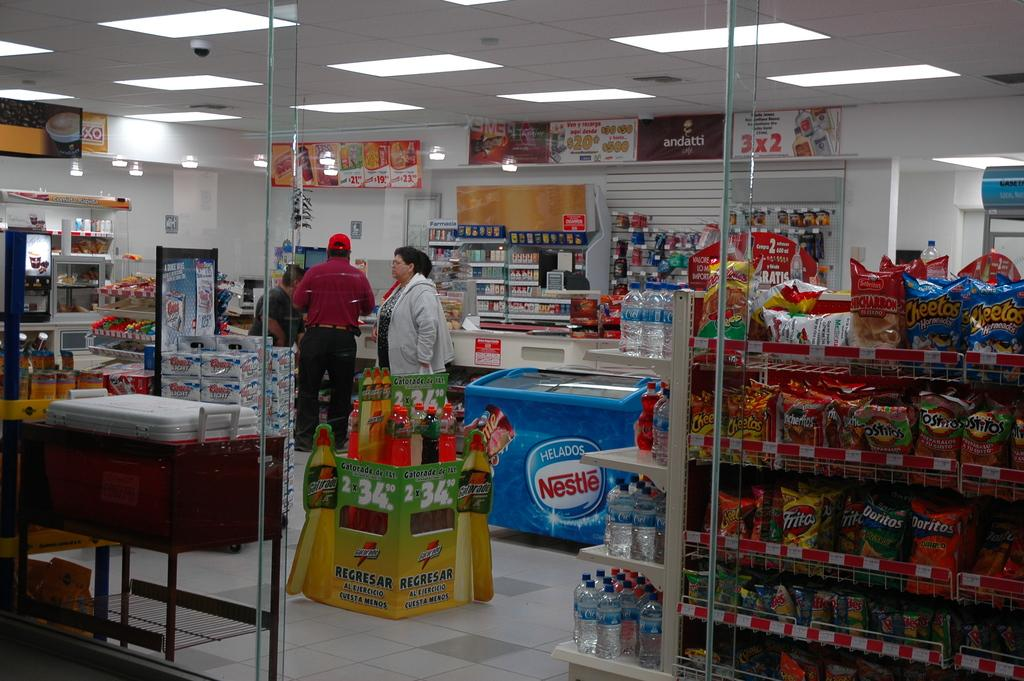<image>
Offer a succinct explanation of the picture presented. A shop interior with a shelf of Doritos. 